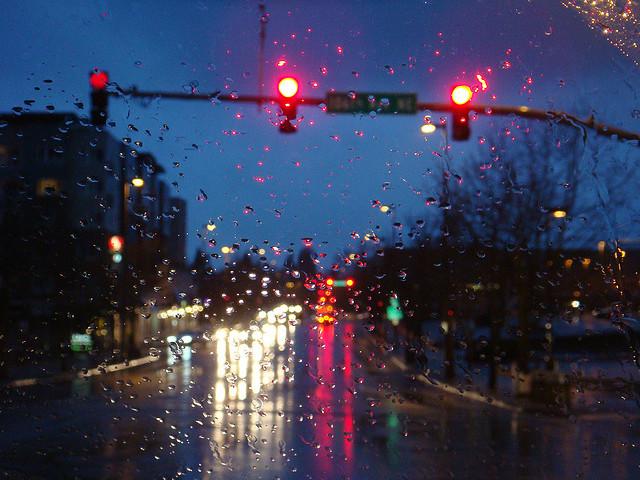Is it snowing?
Give a very brief answer. No. Is it raining outside?
Concise answer only. Yes. Is it raining?
Concise answer only. Yes. How many lights are red?
Be succinct. 3. 